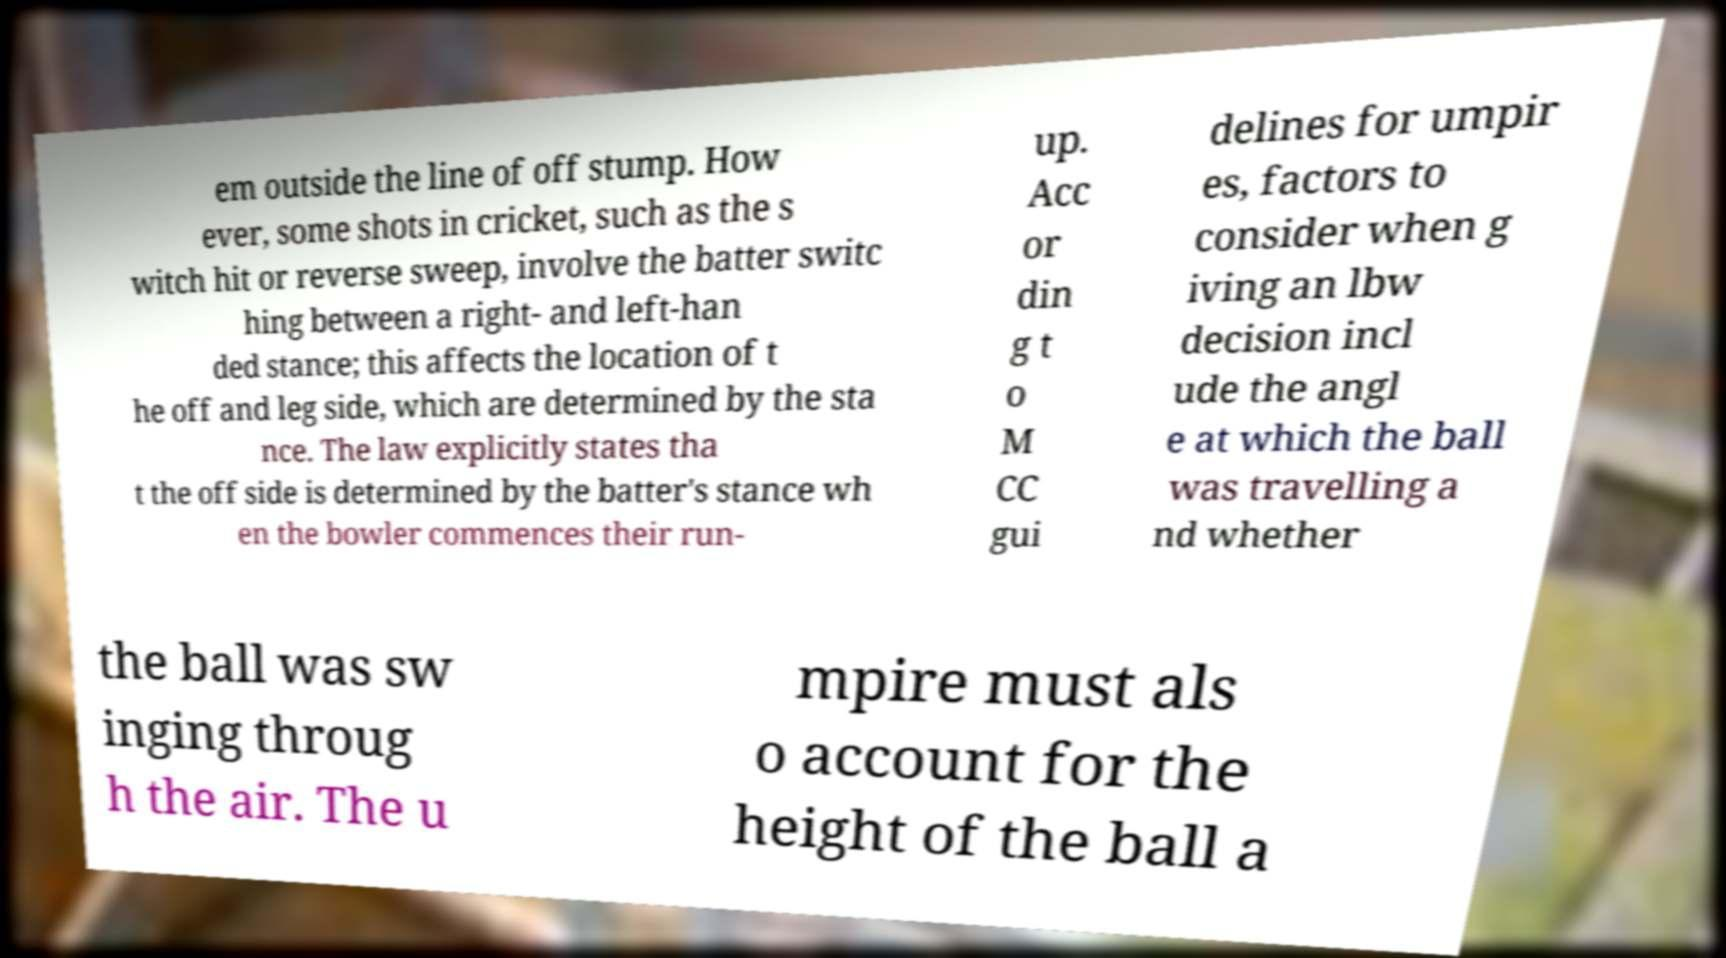There's text embedded in this image that I need extracted. Can you transcribe it verbatim? em outside the line of off stump. How ever, some shots in cricket, such as the s witch hit or reverse sweep, involve the batter switc hing between a right- and left-han ded stance; this affects the location of t he off and leg side, which are determined by the sta nce. The law explicitly states tha t the off side is determined by the batter's stance wh en the bowler commences their run- up. Acc or din g t o M CC gui delines for umpir es, factors to consider when g iving an lbw decision incl ude the angl e at which the ball was travelling a nd whether the ball was sw inging throug h the air. The u mpire must als o account for the height of the ball a 